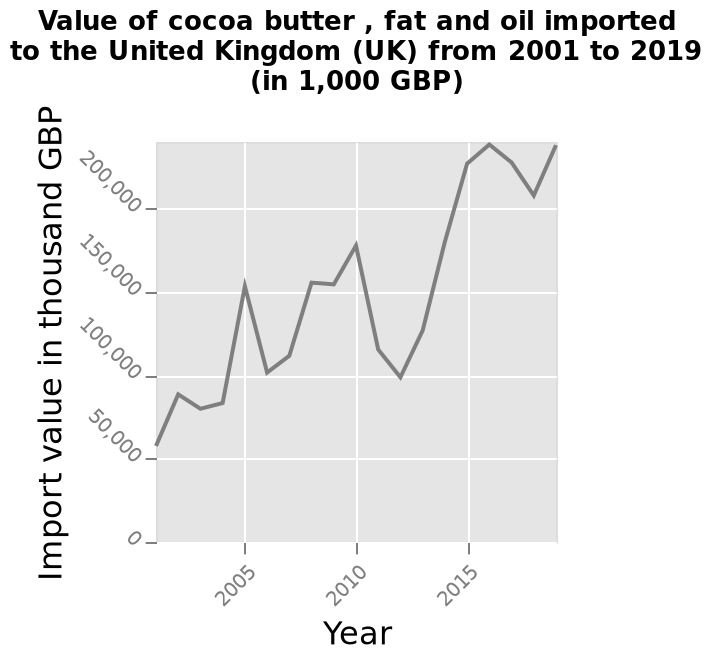<image>
How would you describe the overall trend in import value from 2001 to 2019? The overall trend in the import value from 2001 to 2019 is positive, with some minor setbacks. Was there any setback in the import value after 2010?  Yes, there was a drawback in the import value after 2010. What is measured on the y-axis?  The y-axis measures the Import value in thousand GBP on a linear scale ranging from 0 to 200,000. 